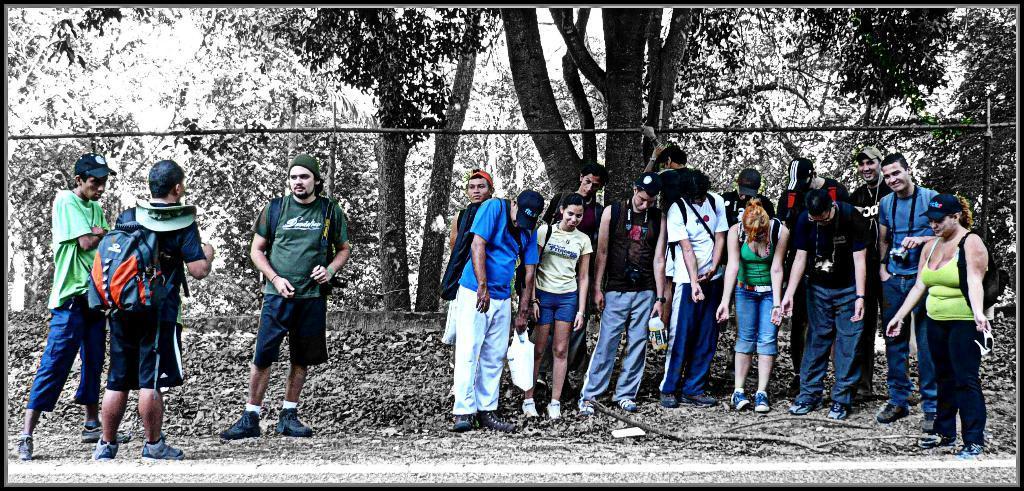Describe this image in one or two sentences. In this image I can see the group of people with different color dresses. I can see few people are wearing the bags and few are wearing the caps. In the background I can see many trees. 